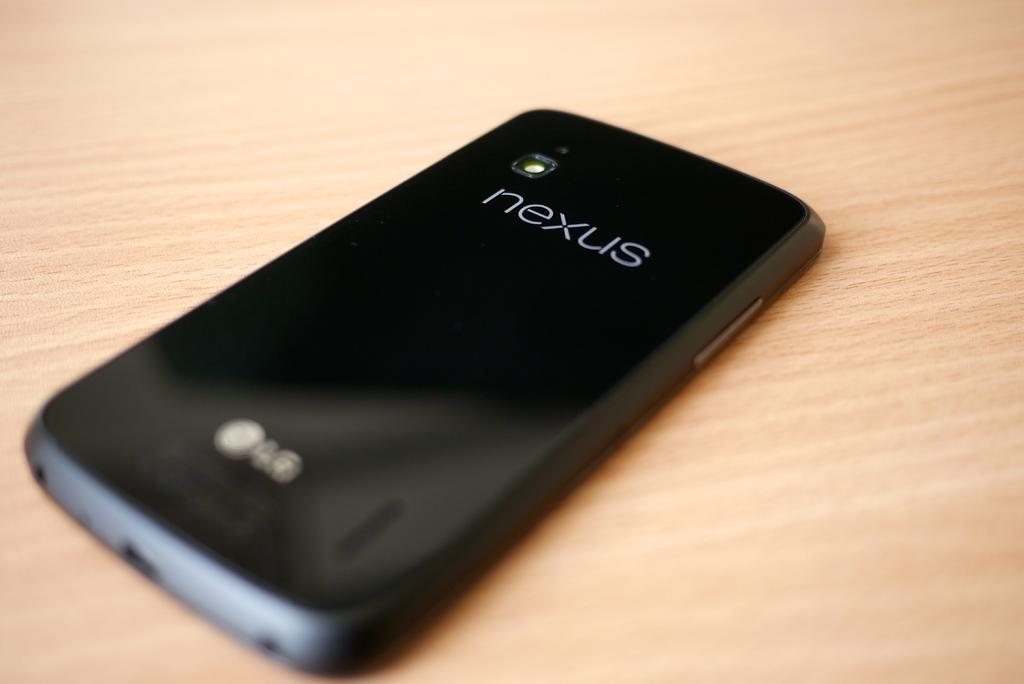<image>
Relay a brief, clear account of the picture shown. A black phone with Nexus on its back lies on a wooden table. 